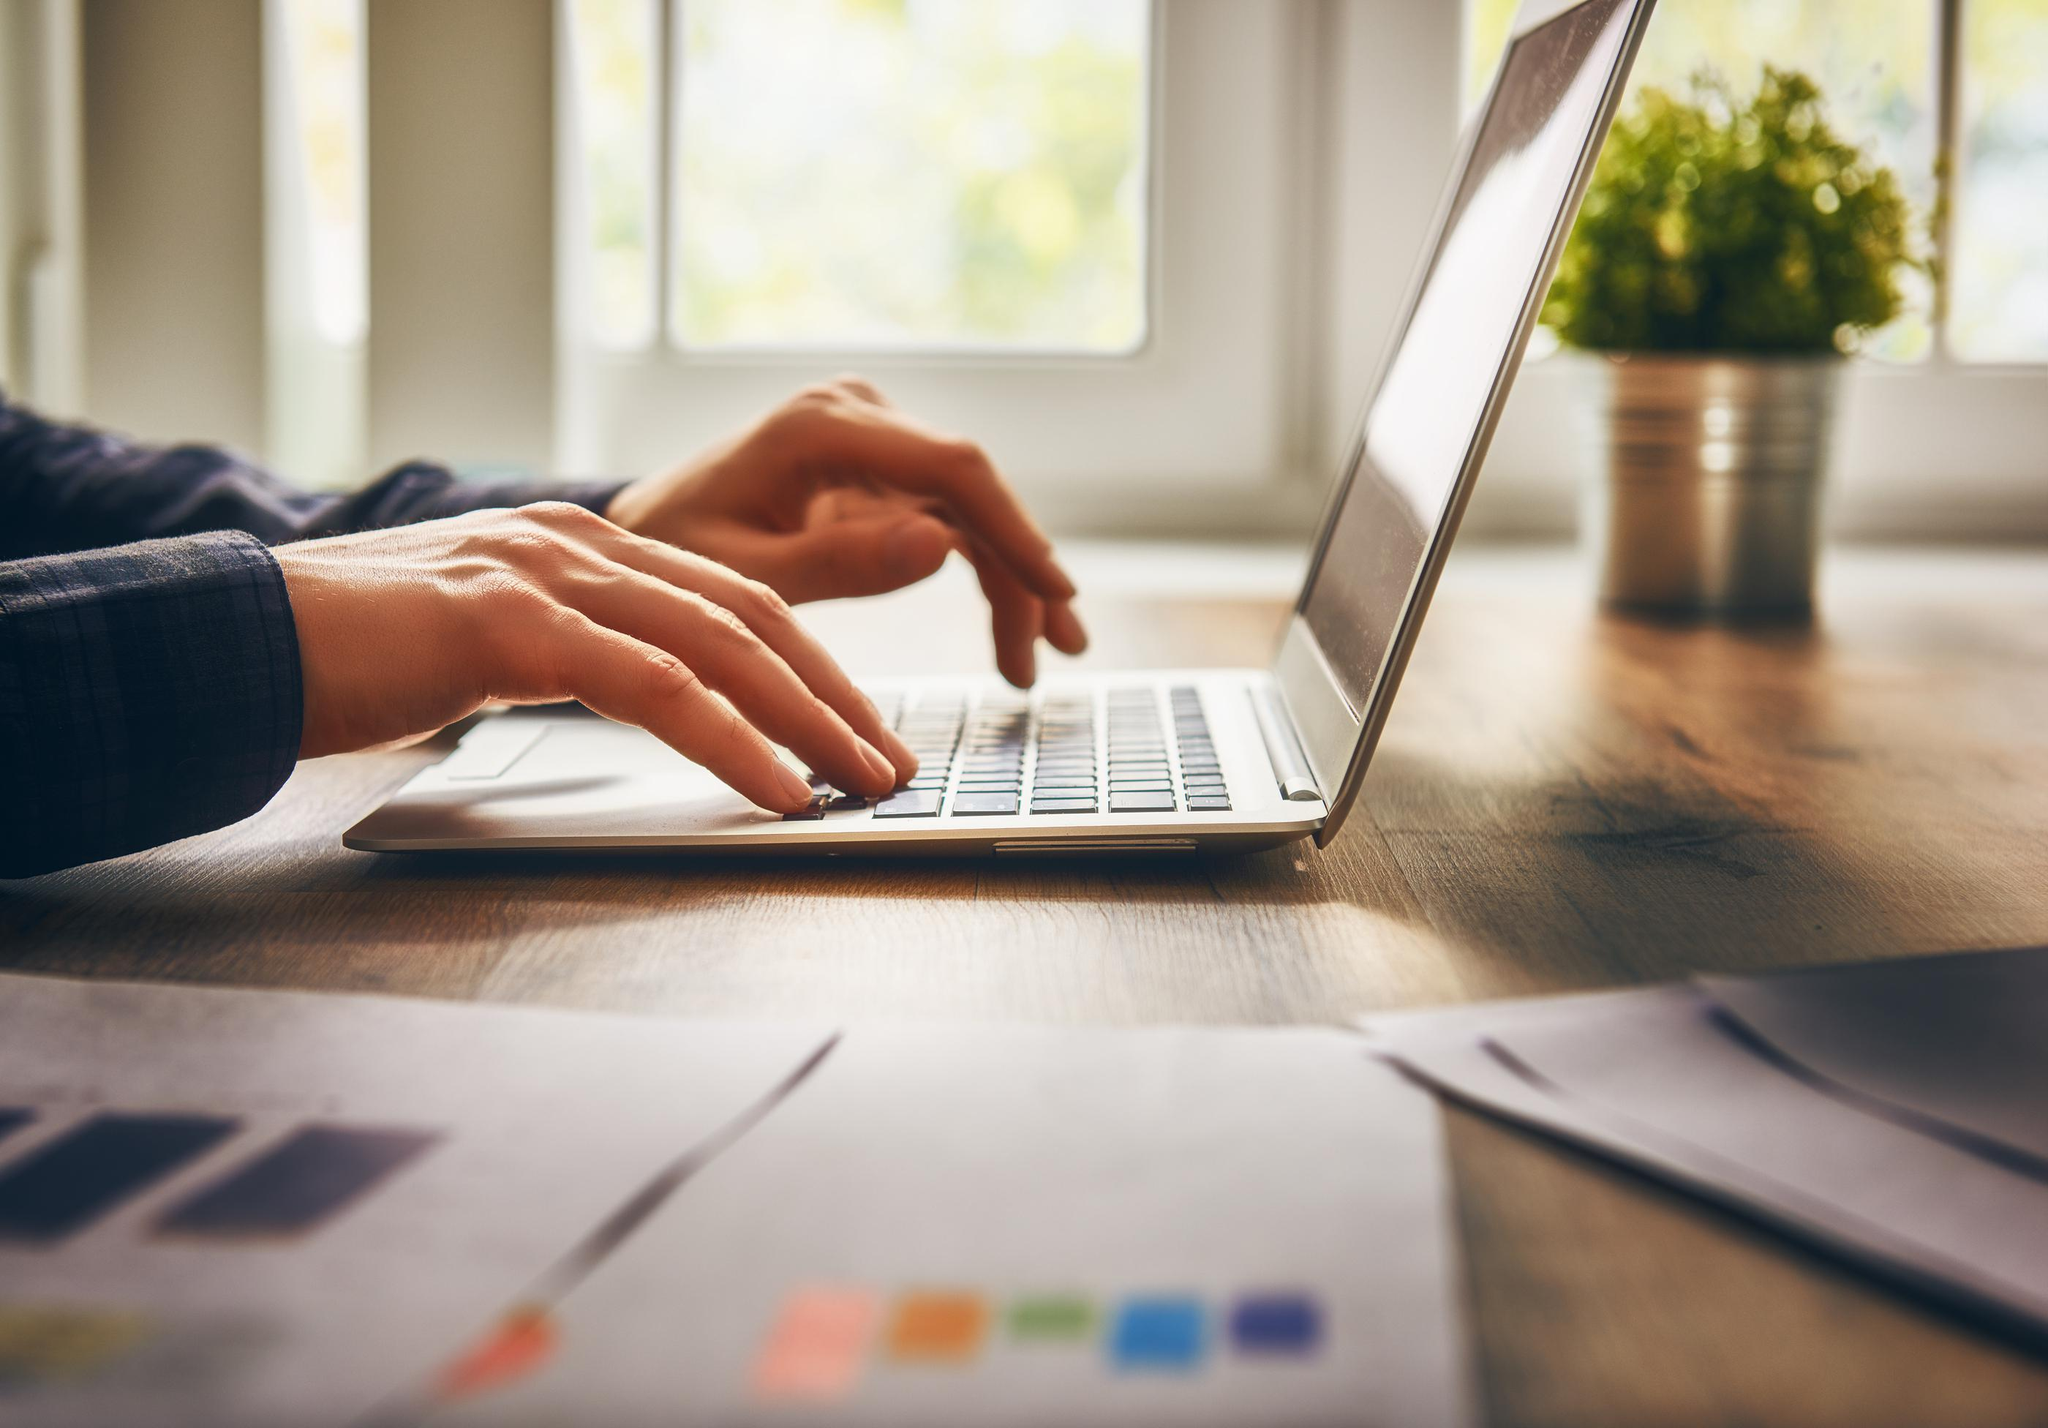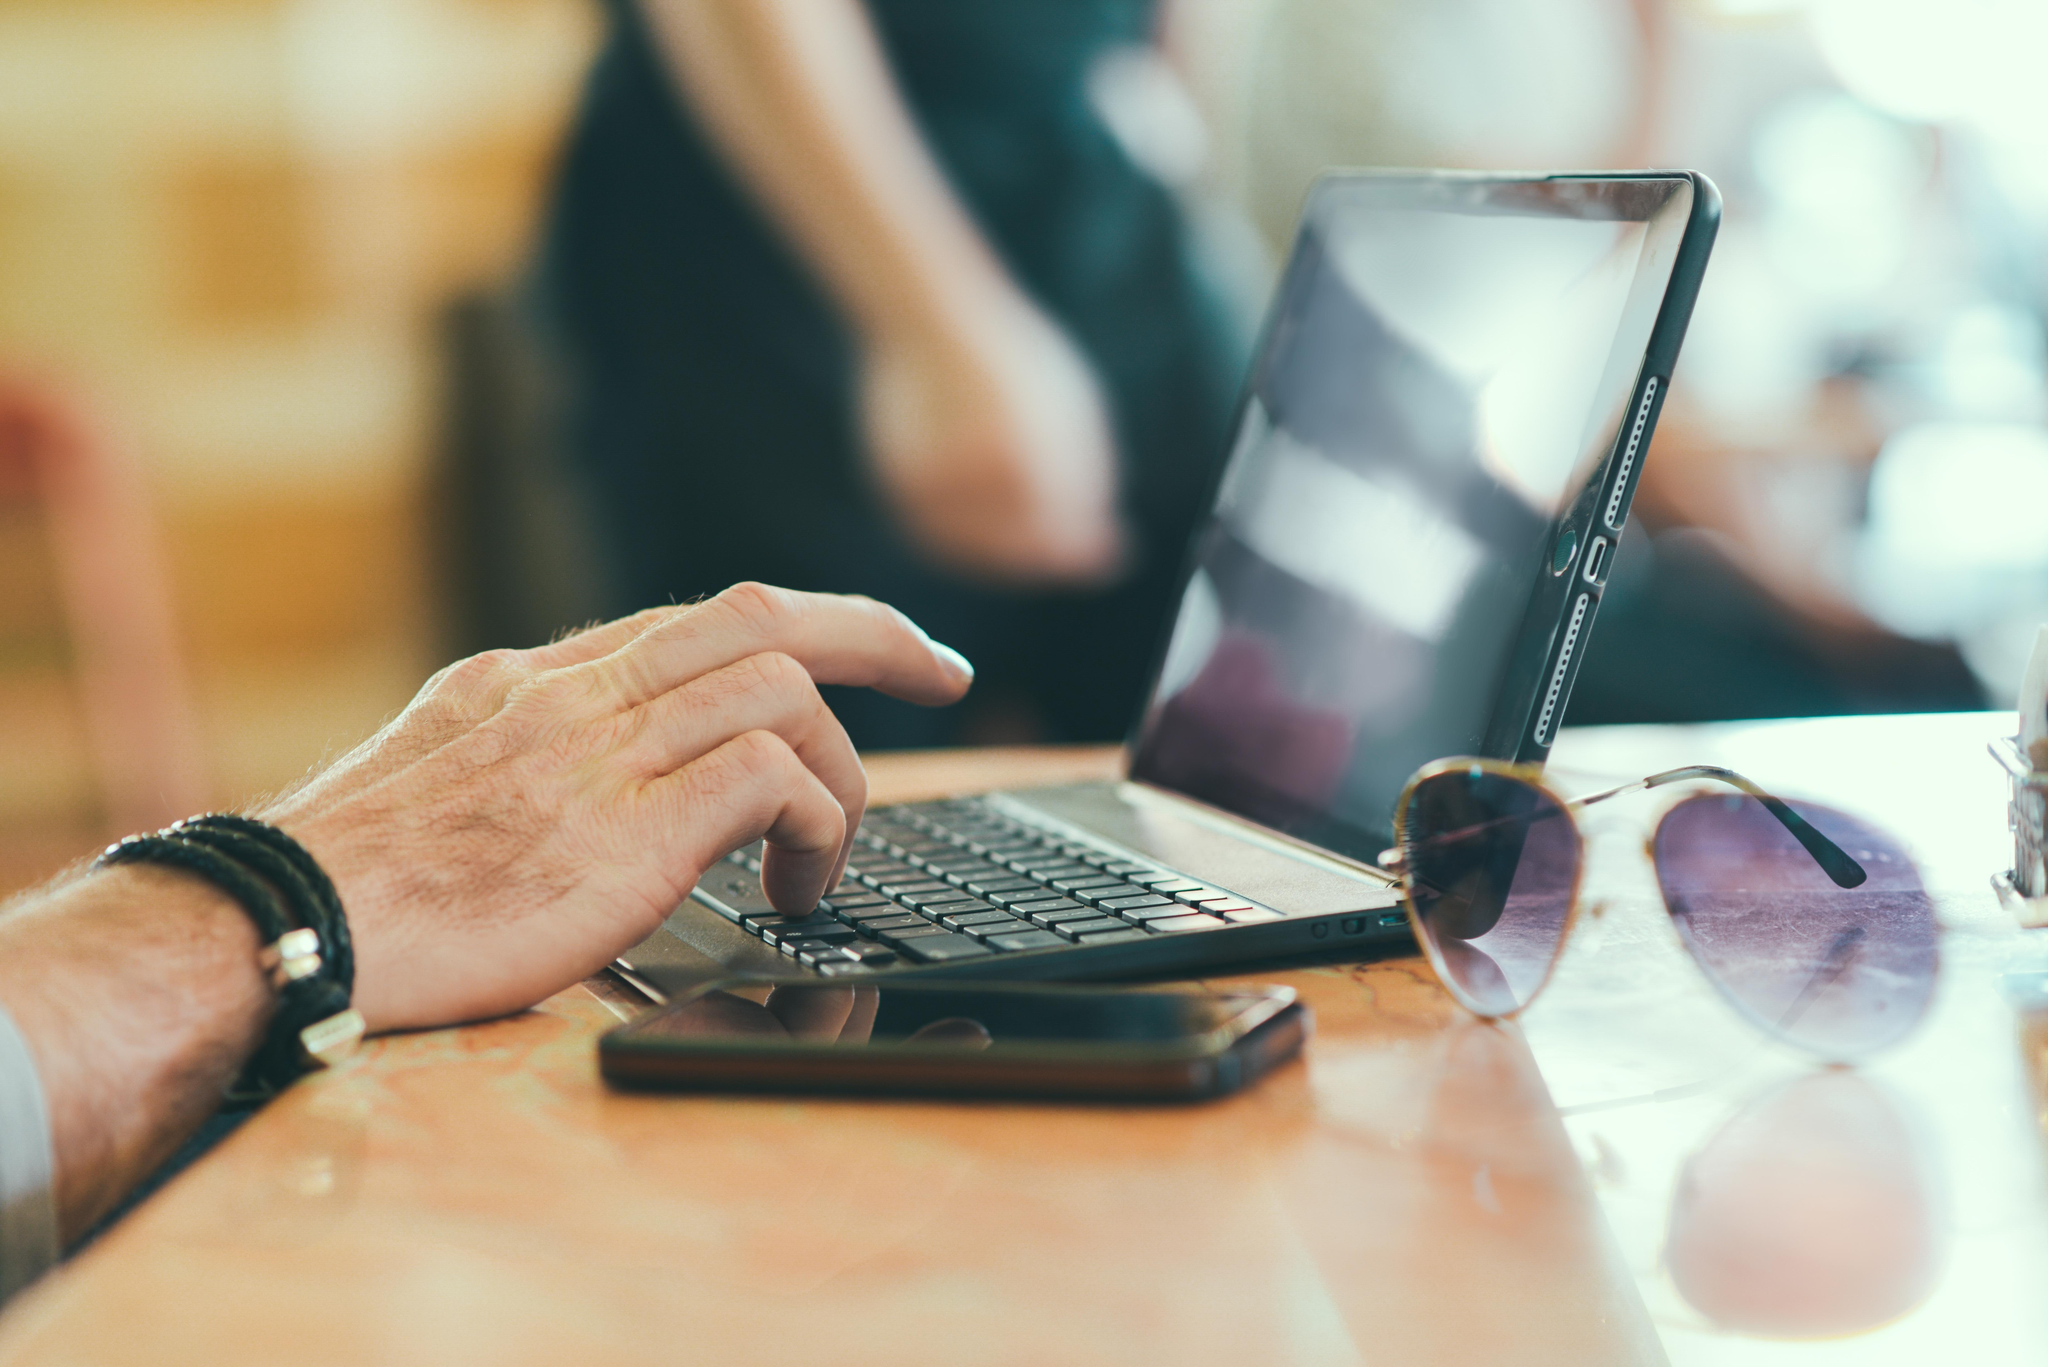The first image is the image on the left, the second image is the image on the right. Given the left and right images, does the statement "Each image shows at least one hand on the keyboard of a laptop with its open screen facing leftward." hold true? Answer yes or no. Yes. The first image is the image on the left, the second image is the image on the right. Evaluate the accuracy of this statement regarding the images: "A pen is on a paper near a laptop in at least one of the images.". Is it true? Answer yes or no. No. 